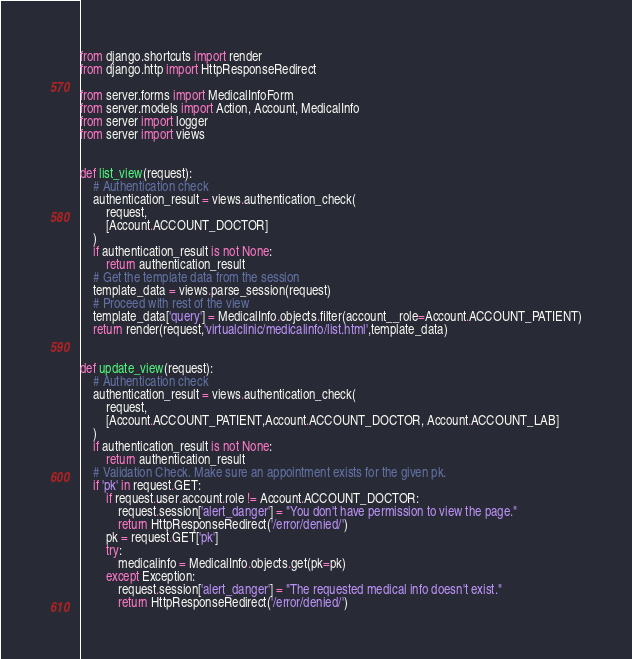Convert code to text. <code><loc_0><loc_0><loc_500><loc_500><_Python_>from django.shortcuts import render
from django.http import HttpResponseRedirect

from server.forms import MedicalInfoForm
from server.models import Action, Account, MedicalInfo
from server import logger
from server import views


def list_view(request):
    # Authentication check
    authentication_result = views.authentication_check(
        request,
        [Account.ACCOUNT_DOCTOR]
    )
    if authentication_result is not None:
        return authentication_result
    # Get the template data from the session
    template_data = views.parse_session(request)
    # Proceed with rest of the view
    template_data['query'] = MedicalInfo.objects.filter(account__role=Account.ACCOUNT_PATIENT)
    return render(request,'virtualclinic/medicalinfo/list.html',template_data)


def update_view(request):
    # Authentication check
    authentication_result = views.authentication_check(
        request,
        [Account.ACCOUNT_PATIENT,Account.ACCOUNT_DOCTOR, Account.ACCOUNT_LAB]
    )
    if authentication_result is not None:
        return authentication_result
    # Validation Check. Make sure an appointment exists for the given pk.
    if 'pk' in request.GET:
        if request.user.account.role != Account.ACCOUNT_DOCTOR:
            request.session['alert_danger'] = "You don't have permission to view the page."
            return HttpResponseRedirect('/error/denied/')
        pk = request.GET['pk']
        try:
            medicalinfo = MedicalInfo.objects.get(pk=pk)
        except Exception:
            request.session['alert_danger'] = "The requested medical info doesn't exist."
            return HttpResponseRedirect('/error/denied/')</code> 